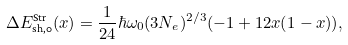<formula> <loc_0><loc_0><loc_500><loc_500>\Delta E ^ { \text {Str} } _ { \text {sh,0} } ( x ) = \frac { 1 } { 2 4 } \hbar { \omega } _ { 0 } ( 3 N _ { e } ) ^ { 2 / 3 } ( - 1 + 1 2 x ( 1 - x ) ) ,</formula> 